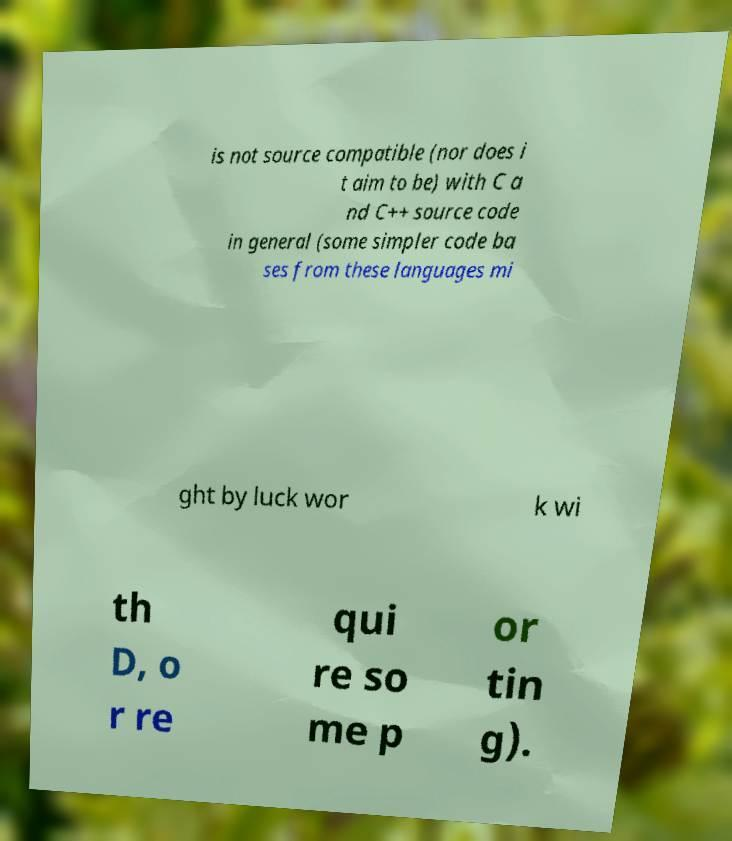Can you read and provide the text displayed in the image?This photo seems to have some interesting text. Can you extract and type it out for me? is not source compatible (nor does i t aim to be) with C a nd C++ source code in general (some simpler code ba ses from these languages mi ght by luck wor k wi th D, o r re qui re so me p or tin g). 